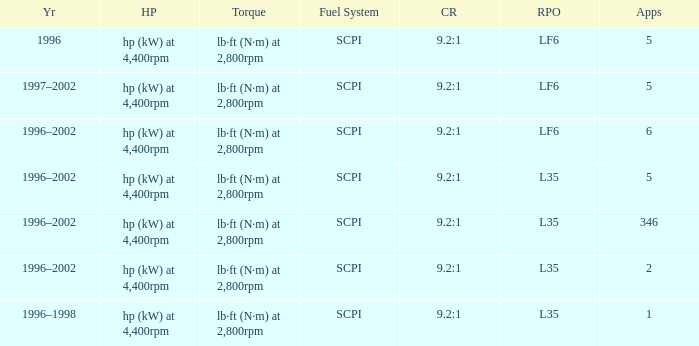What's the compression ratio of the model with L35 RPO and 5 applications? 9.2:1. 